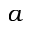Convert formula to latex. <formula><loc_0><loc_0><loc_500><loc_500>a</formula> 